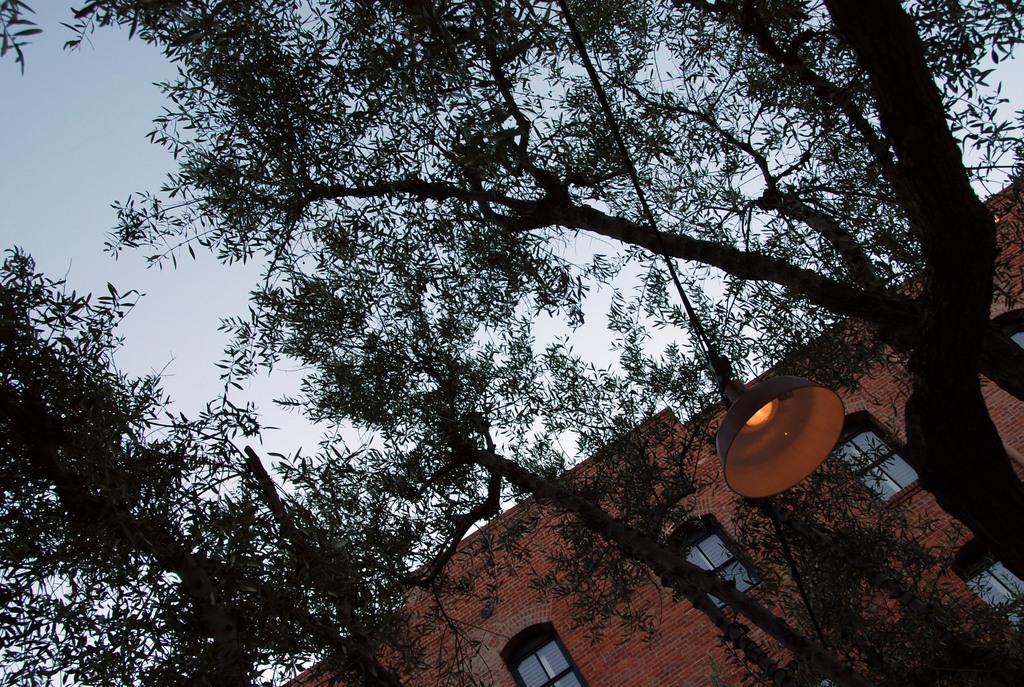In one or two sentences, can you explain what this image depicts? There are trees in the foreground area, there is a lamp and a rope on the right side. There is a building and sky in the background area. 